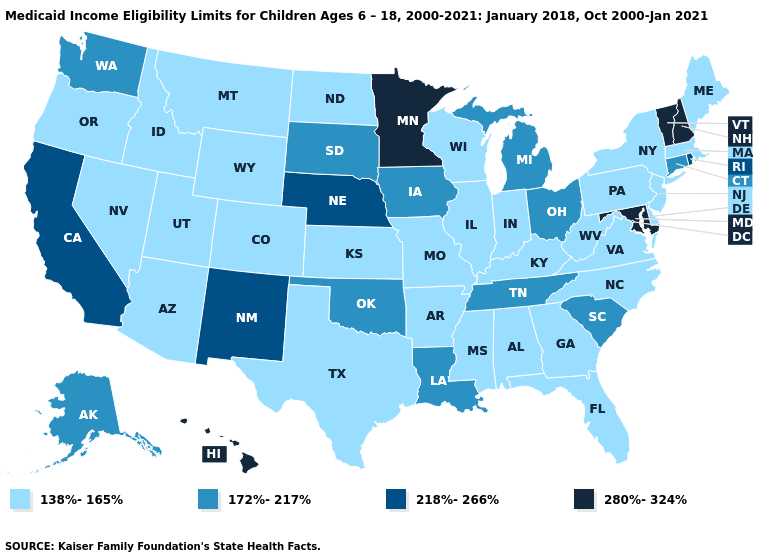Name the states that have a value in the range 218%-266%?
Quick response, please. California, Nebraska, New Mexico, Rhode Island. Which states hav the highest value in the MidWest?
Short answer required. Minnesota. Does the first symbol in the legend represent the smallest category?
Be succinct. Yes. Does Arkansas have the highest value in the South?
Quick response, please. No. Among the states that border Illinois , does Iowa have the lowest value?
Write a very short answer. No. Name the states that have a value in the range 138%-165%?
Answer briefly. Alabama, Arizona, Arkansas, Colorado, Delaware, Florida, Georgia, Idaho, Illinois, Indiana, Kansas, Kentucky, Maine, Massachusetts, Mississippi, Missouri, Montana, Nevada, New Jersey, New York, North Carolina, North Dakota, Oregon, Pennsylvania, Texas, Utah, Virginia, West Virginia, Wisconsin, Wyoming. Does Tennessee have a lower value than North Carolina?
Keep it brief. No. Name the states that have a value in the range 172%-217%?
Concise answer only. Alaska, Connecticut, Iowa, Louisiana, Michigan, Ohio, Oklahoma, South Carolina, South Dakota, Tennessee, Washington. Is the legend a continuous bar?
Answer briefly. No. Among the states that border Idaho , does Washington have the lowest value?
Concise answer only. No. What is the value of Wisconsin?
Be succinct. 138%-165%. Which states have the lowest value in the West?
Answer briefly. Arizona, Colorado, Idaho, Montana, Nevada, Oregon, Utah, Wyoming. Does Vermont have the lowest value in the USA?
Be succinct. No. Does Iowa have the lowest value in the MidWest?
Write a very short answer. No. Is the legend a continuous bar?
Be succinct. No. 